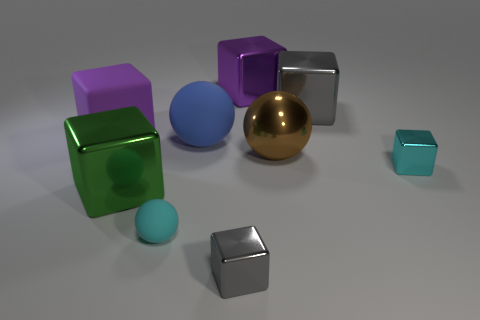Subtract all large gray cubes. How many cubes are left? 5 Subtract all brown cylinders. How many gray blocks are left? 2 Subtract 4 blocks. How many blocks are left? 2 Subtract all purple blocks. How many blocks are left? 4 Subtract all gray blocks. Subtract all blue cylinders. How many blocks are left? 4 Add 1 cyan metallic blocks. How many objects exist? 10 Subtract all balls. How many objects are left? 6 Add 4 gray metallic things. How many gray metallic things are left? 6 Add 9 purple rubber cylinders. How many purple rubber cylinders exist? 9 Subtract 0 brown cubes. How many objects are left? 9 